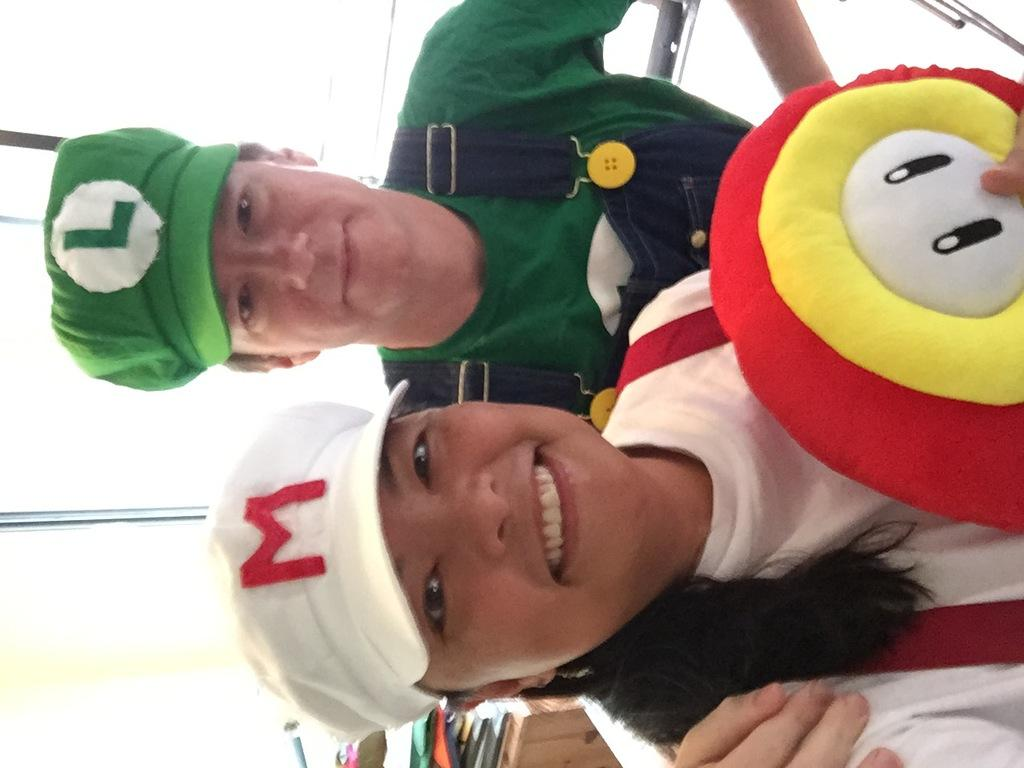How many people are in the image? There are two persons in the image. What is the color and pattern of the dress worn by one of the persons? One person is wearing a white and red color dress. What can be seen in the background of the image? The background of the image is white. What purpose does the pencil serve in the image? There is no pencil present in the image, so it cannot serve any purpose in this context. 